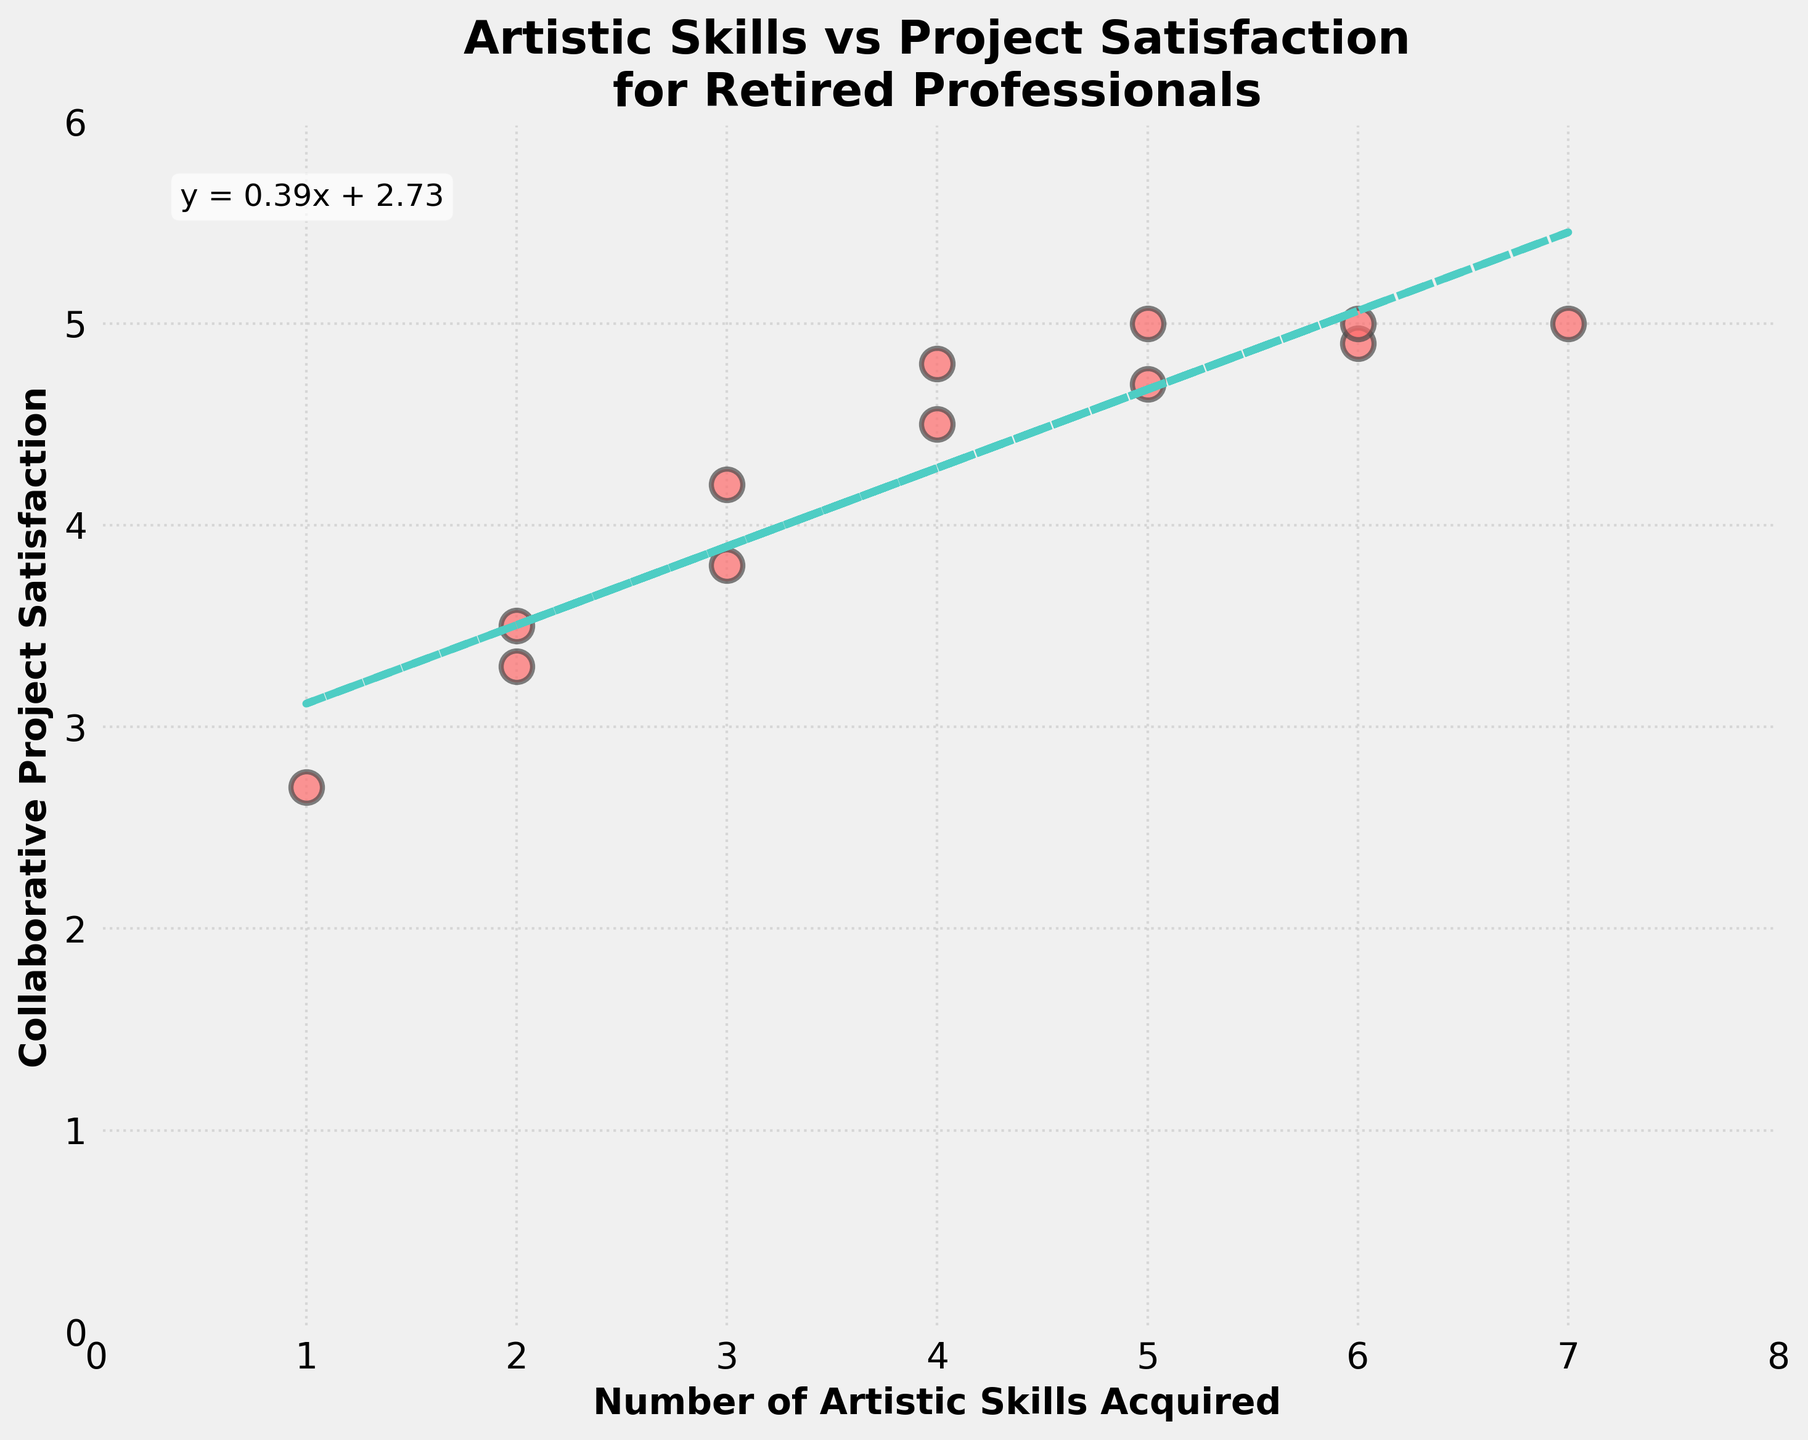What is the title of the scatter plot? The title of the scatter plot is present at the top of the plot. It reads "Artistic Skills vs Project Satisfaction\nfor Retired Professionals".
Answer: Artistic Skills vs Project Satisfaction for Retired Professionals How many data points are there in the scatter plot? The number of data points can be counted directly from the scatter plot. There are 12 distinctive dots visible on the plot.
Answer: 12 What is the general trend indicated by the trend line? The trend line is upward sloping, which suggests a positive relationship between the number of artistic skills acquired post-retirement and satisfaction from collaborative projects.
Answer: Positive relationship What is the range of values for the 'Number of Artistic Skills Acquired' axis? The x-axis shows values from 0 to 8, where the data points range from 1 to 7.
Answer: 0 to 8 Which data point represents the highest satisfaction from collaborative projects, and what are its coordinates? The highest satisfaction value seen on the y-axis is 5.0. Checking over the plot, the coordinates corresponding to y = 5.0 are (5, 5.0), (6, 5.0), and (7, 5.0).
Answer: (5, 5.0), (6, 5.0), (7, 5.0) What is the linear equation of the trend line? The linear equation of the trend line is mentioned in the text annotation inside the plot. It reads as y = 0.33x + 3.16.
Answer: y = 0.33x + 3.16 How many artistic skills are acquired for a satisfaction level of approximately 4.5 according to the trend line? Substituting y = 4.5 into the trend line equation y = 0.33x + 3.16: 4.5 = 0.33x + 3.16. Solving this gives x = (4.5 - 3.16) / 0.33 ≈ 4.06.
Answer: Approximately 4 Which data point(s) do not follow the trend indicated by the trend line? To identify outliers, observe data points far from the trend line. The data points at (1, 2.7) and (2, 3.3) are significantly below the trend line.
Answer: (1, 2.7) and (2, 3.3) For a retired professional with 3 artistic skills acquired, what is the expected satisfaction from collaborative projects according to the trend line? Substituting x = 3 into the trend line equation y = 0.33x + 3.16: y = 0.33*3 + 3.16 = 1 + 3.16 = 4.15.
Answer: 4.15 